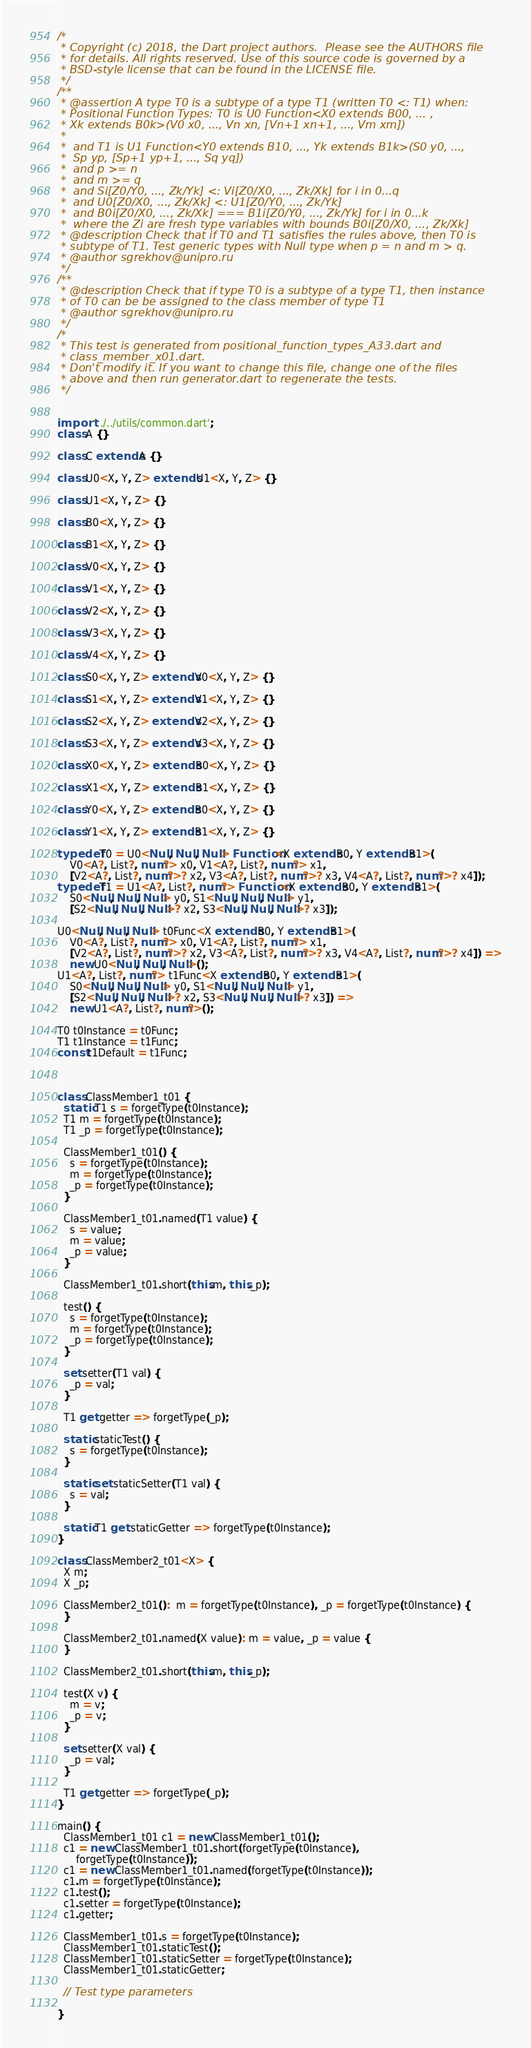Convert code to text. <code><loc_0><loc_0><loc_500><loc_500><_Dart_>/*
 * Copyright (c) 2018, the Dart project authors.  Please see the AUTHORS file
 * for details. All rights reserved. Use of this source code is governed by a
 * BSD-style license that can be found in the LICENSE file.
 */
/**
 * @assertion A type T0 is a subtype of a type T1 (written T0 <: T1) when:
 * Positional Function Types: T0 is U0 Function<X0 extends B00, ... ,
 * Xk extends B0k>(V0 x0, ..., Vn xn, [Vn+1 xn+1, ..., Vm xm])
 *
 *  and T1 is U1 Function<Y0 extends B10, ..., Yk extends B1k>(S0 y0, ...,
 *  Sp yp, [Sp+1 yp+1, ..., Sq yq])
 *  and p >= n
 *  and m >= q
 *  and Si[Z0/Y0, ..., Zk/Yk] <: Vi[Z0/X0, ..., Zk/Xk] for i in 0...q
 *  and U0[Z0/X0, ..., Zk/Xk] <: U1[Z0/Y0, ..., Zk/Yk]
 *  and B0i[Z0/X0, ..., Zk/Xk] === B1i[Z0/Y0, ..., Zk/Yk] for i in 0...k
 *  where the Zi are fresh type variables with bounds B0i[Z0/X0, ..., Zk/Xk]
 * @description Check that if T0 and T1 satisfies the rules above, then T0 is
 * subtype of T1. Test generic types with Null type when p = n and m > q.
 * @author sgrekhov@unipro.ru
 */
/**
 * @description Check that if type T0 is a subtype of a type T1, then instance
 * of T0 can be be assigned to the class member of type T1
 * @author sgrekhov@unipro.ru
 */
/*
 * This test is generated from positional_function_types_A33.dart and 
 * class_member_x01.dart.
 * Don't modify it. If you want to change this file, change one of the files 
 * above and then run generator.dart to regenerate the tests.
 */


import '../../utils/common.dart';
class A {}

class C extends A {}

class U0<X, Y, Z> extends U1<X, Y, Z> {}

class U1<X, Y, Z> {}

class B0<X, Y, Z> {}

class B1<X, Y, Z> {}

class V0<X, Y, Z> {}

class V1<X, Y, Z> {}

class V2<X, Y, Z> {}

class V3<X, Y, Z> {}

class V4<X, Y, Z> {}

class S0<X, Y, Z> extends V0<X, Y, Z> {}

class S1<X, Y, Z> extends V1<X, Y, Z> {}

class S2<X, Y, Z> extends V2<X, Y, Z> {}

class S3<X, Y, Z> extends V3<X, Y, Z> {}

class X0<X, Y, Z> extends B0<X, Y, Z> {}

class X1<X, Y, Z> extends B1<X, Y, Z> {}

class Y0<X, Y, Z> extends B0<X, Y, Z> {}

class Y1<X, Y, Z> extends B1<X, Y, Z> {}

typedef T0 = U0<Null, Null, Null> Function<X extends B0, Y extends B1>(
    V0<A?, List?, num?> x0, V1<A?, List?, num?> x1,
    [V2<A?, List?, num?>? x2, V3<A?, List?, num?>? x3, V4<A?, List?, num?>? x4]);
typedef T1 = U1<A?, List?, num?> Function<X extends B0, Y extends B1>(
    S0<Null, Null, Null> y0, S1<Null, Null, Null> y1,
    [S2<Null, Null, Null>? x2, S3<Null, Null, Null>? x3]);

U0<Null, Null, Null> t0Func<X extends B0, Y extends B1>(
    V0<A?, List?, num?> x0, V1<A?, List?, num?> x1,
    [V2<A?, List?, num?>? x2, V3<A?, List?, num?>? x3, V4<A?, List?, num?>? x4]) =>
    new U0<Null, Null, Null>();
U1<A?, List?, num?> t1Func<X extends B0, Y extends B1>(
    S0<Null, Null, Null> y0, S1<Null, Null, Null> y1,
    [S2<Null, Null, Null>? x2, S3<Null, Null, Null>? x3]) =>
    new U1<A?, List?, num?>();

T0 t0Instance = t0Func;
T1 t1Instance = t1Func;
const t1Default = t1Func;



class ClassMember1_t01 {
  static T1 s = forgetType(t0Instance);
  T1 m = forgetType(t0Instance);
  T1 _p = forgetType(t0Instance);

  ClassMember1_t01() {
    s = forgetType(t0Instance);
    m = forgetType(t0Instance);
    _p = forgetType(t0Instance);
  }

  ClassMember1_t01.named(T1 value) {
    s = value;
    m = value;
    _p = value;
  }

  ClassMember1_t01.short(this.m, this._p);

  test() {
    s = forgetType(t0Instance);
    m = forgetType(t0Instance);
    _p = forgetType(t0Instance);
  }

  set setter(T1 val) {
    _p = val;
  }

  T1 get getter => forgetType(_p);

  static staticTest() {
    s = forgetType(t0Instance);
  }

  static set staticSetter(T1 val) {
    s = val;
  }

  static T1 get staticGetter => forgetType(t0Instance);
}

class ClassMember2_t01<X> {
  X m;
  X _p;

  ClassMember2_t01():  m = forgetType(t0Instance), _p = forgetType(t0Instance) {
  }

  ClassMember2_t01.named(X value): m = value, _p = value {
  }

  ClassMember2_t01.short(this.m, this._p);

  test(X v) {
    m = v;
    _p = v;
  }

  set setter(X val) {
    _p = val;
  }

  T1 get getter => forgetType(_p);
}

main() {
  ClassMember1_t01 c1 = new ClassMember1_t01();
  c1 = new ClassMember1_t01.short(forgetType(t0Instance),
      forgetType(t0Instance));
  c1 = new ClassMember1_t01.named(forgetType(t0Instance));
  c1.m = forgetType(t0Instance);
  c1.test();
  c1.setter = forgetType(t0Instance);
  c1.getter;

  ClassMember1_t01.s = forgetType(t0Instance);
  ClassMember1_t01.staticTest();
  ClassMember1_t01.staticSetter = forgetType(t0Instance);
  ClassMember1_t01.staticGetter;

  // Test type parameters

}

</code> 